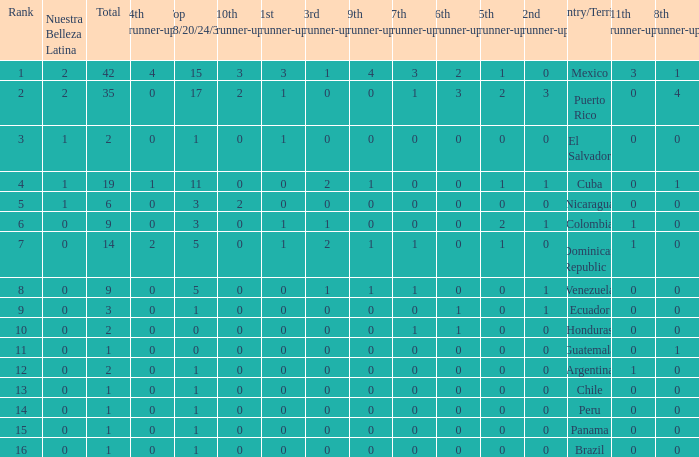What is the 3rd runner-up of the country with more than 0 9th runner-up, an 11th runner-up of 0, and the 1st runner-up greater than 0? None. 